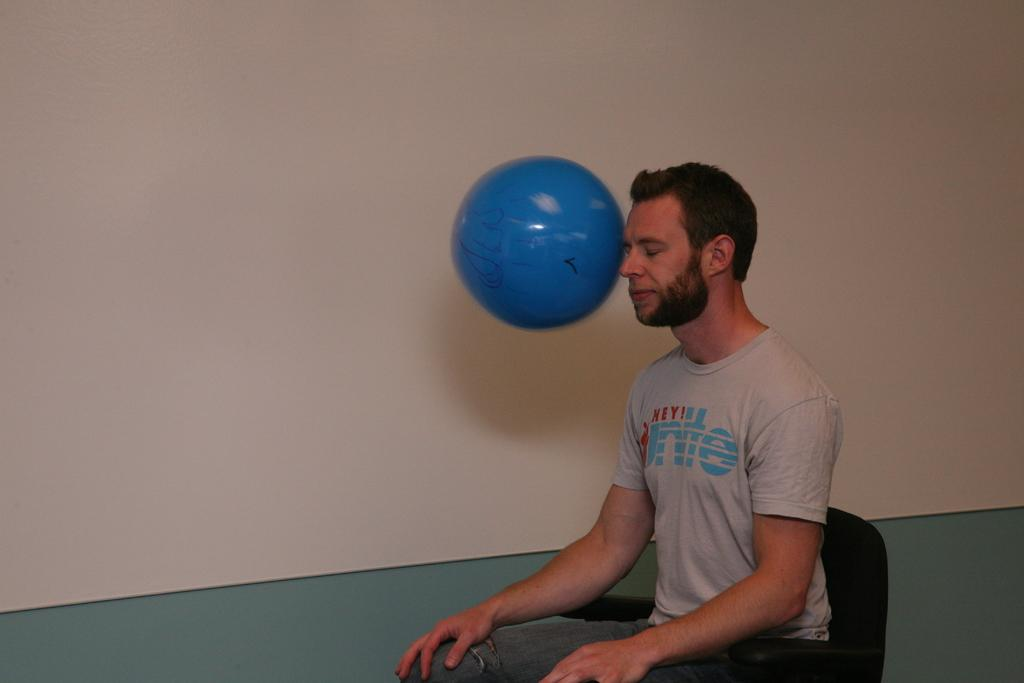What is the person in the image doing? The person is sitting on a chair in the image. What object is in front of the person? There is a blue ball in front of the person. What is behind the person in the image? There is a wall at the back of the person. Where is the nest located in the image? There is no nest present in the image. What type of discussion is happening between the person and the wall in the image? There is no discussion happening between the person and the wall in the image, as the wall is a stationary object. 